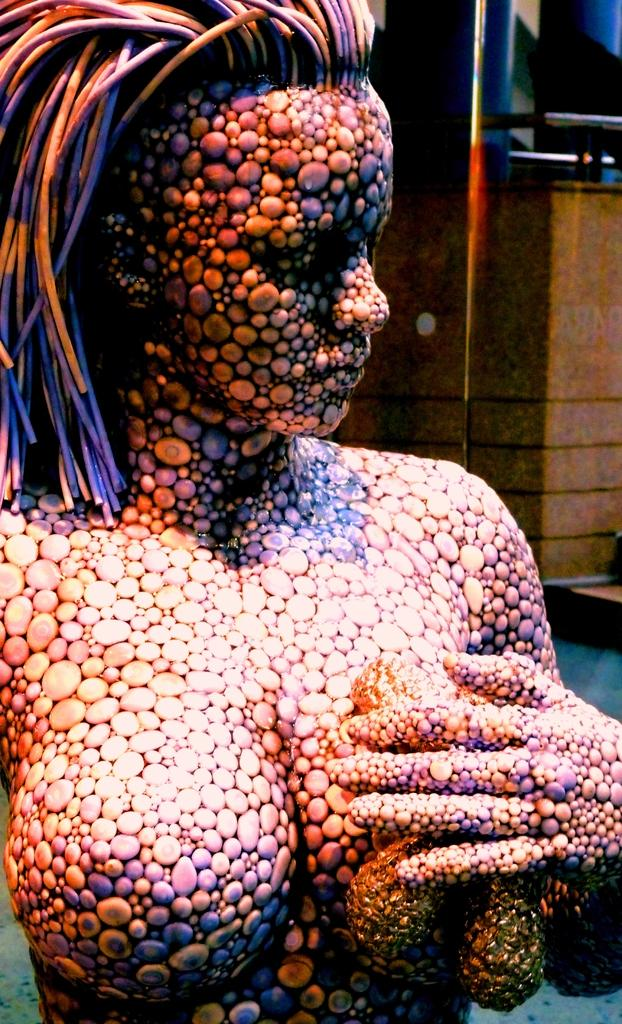What is the main subject in the image? There is a statue in the image. What can be seen in the background of the image? There is a wall and a glass in the background of the image. What type of jelly can be seen on the statue in the image? There is no jelly present on the statue in the image. How does the statue contribute to the overall quietness of the scene in the image? The statue itself does not contribute to the quietness of the scene, as it is an inanimate object. 